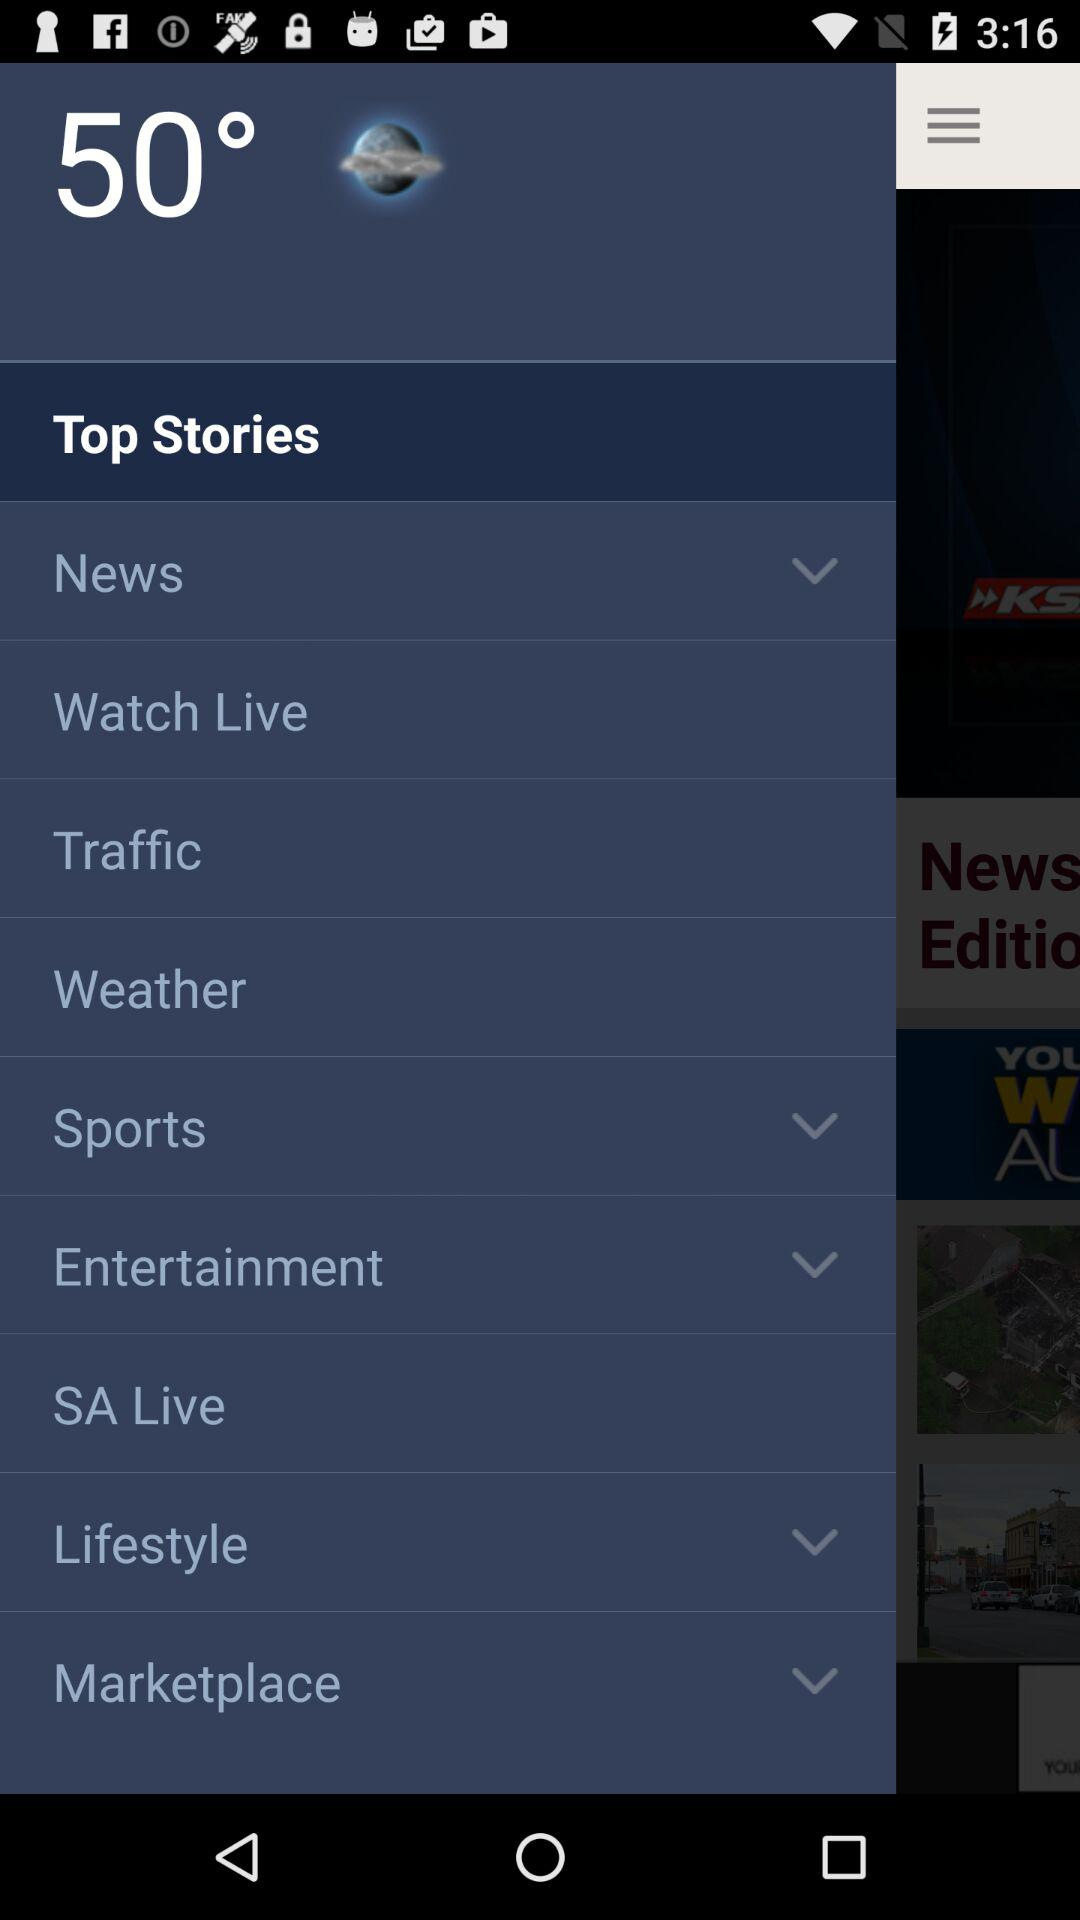Which item is selected in the menu? The selected item in the menu is "Top Stories". 